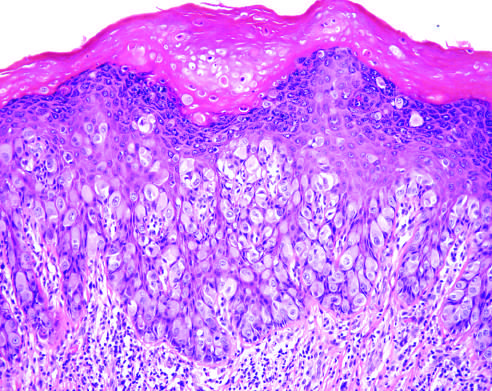what are chronic inflammatory cells present in?
Answer the question using a single word or phrase. The underlying dermis 